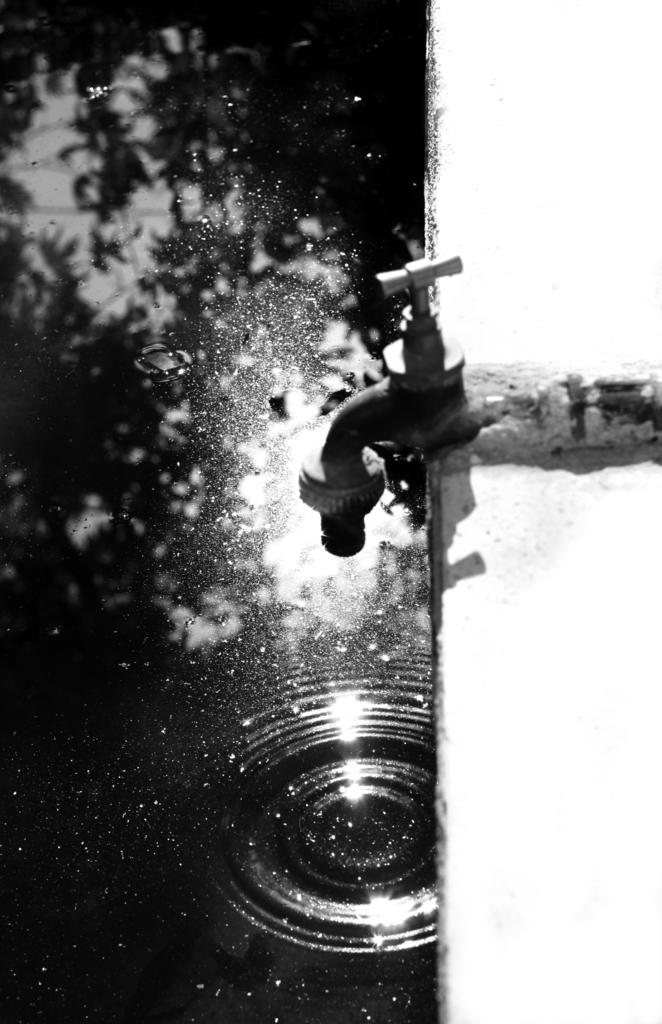What is the color scheme of the image? The image is black and white. What can be seen in the image that is related to water? There is a tap and water in a tub in the image. What type of whip is hanging from the tap in the image? There is no whip present in the image; it only features a tap and water in a tub. 